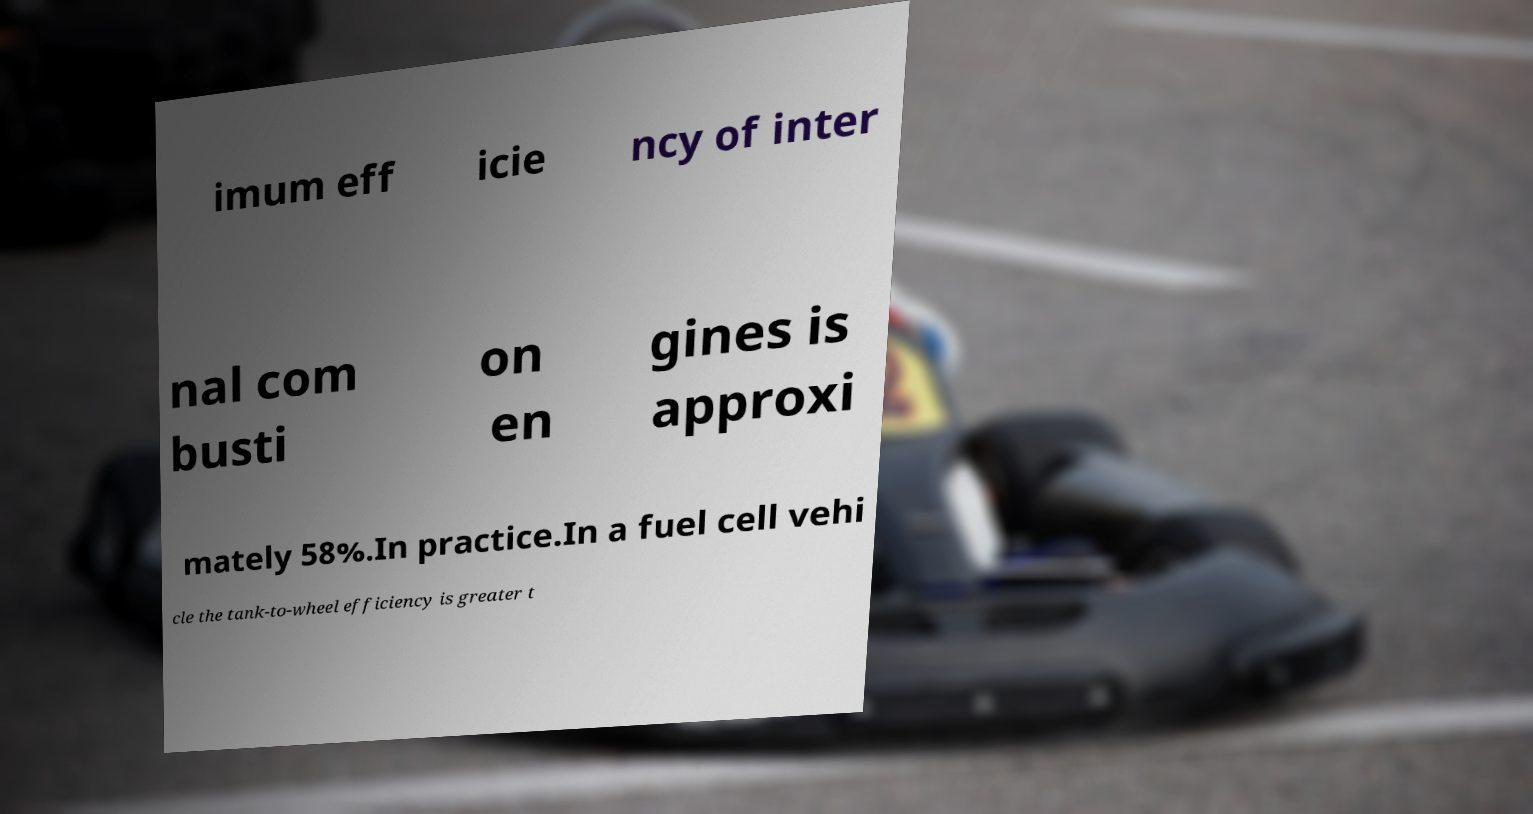Could you extract and type out the text from this image? imum eff icie ncy of inter nal com busti on en gines is approxi mately 58%.In practice.In a fuel cell vehi cle the tank-to-wheel efficiency is greater t 